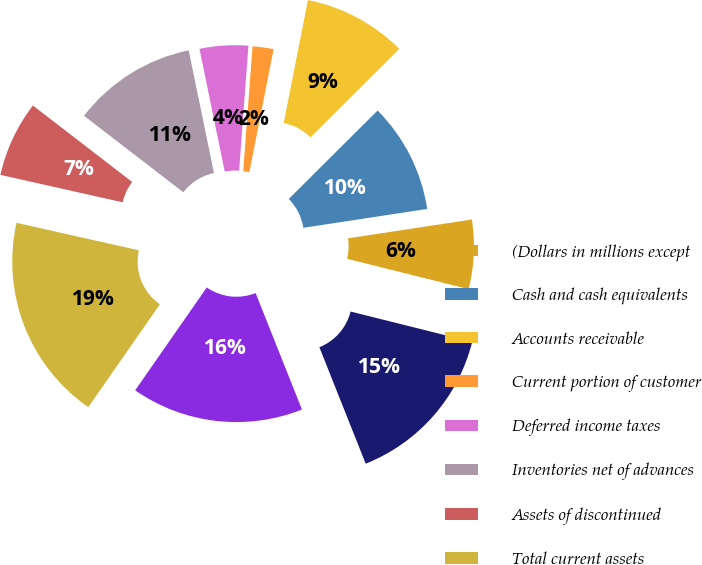Convert chart. <chart><loc_0><loc_0><loc_500><loc_500><pie_chart><fcel>(Dollars in millions except<fcel>Cash and cash equivalents<fcel>Accounts receivable<fcel>Current portion of customer<fcel>Deferred income taxes<fcel>Inventories net of advances<fcel>Assets of discontinued<fcel>Total current assets<fcel>Customer financing<fcel>Property plant and equipment<nl><fcel>6.3%<fcel>10.06%<fcel>9.44%<fcel>1.91%<fcel>4.42%<fcel>11.32%<fcel>6.93%<fcel>18.84%<fcel>15.7%<fcel>15.08%<nl></chart> 